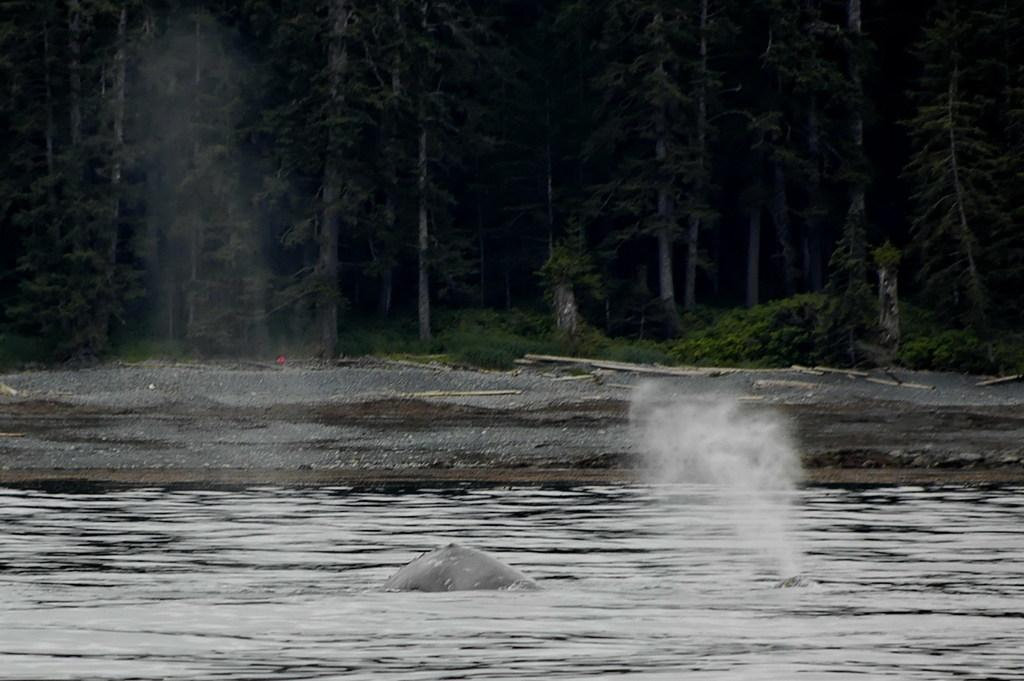What type of animal can be seen in the water in the image? There is an animal in the water in the image. What other elements can be seen in the image besides the animal in the water? There are plants and trees visible in the image. What type of sticks can be seen floating in the oatmeal in the image? There is no oatmeal or sticks present in the image. 